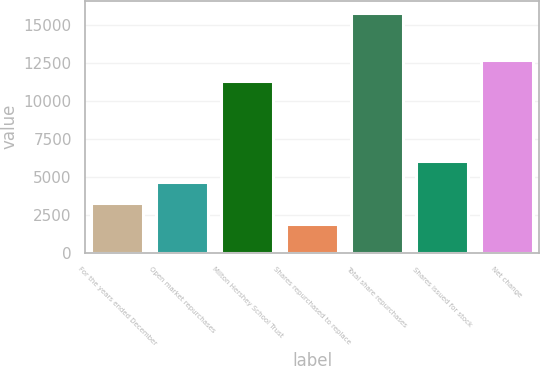Convert chart. <chart><loc_0><loc_0><loc_500><loc_500><bar_chart><fcel>For the years ended December<fcel>Open market repurchases<fcel>Milton Hershey School Trust<fcel>Shares repurchased to replace<fcel>Total share repurchases<fcel>Shares issued for stock<fcel>Net change<nl><fcel>3289.5<fcel>4681<fcel>11282<fcel>1898<fcel>15813<fcel>6072.5<fcel>12673.5<nl></chart> 